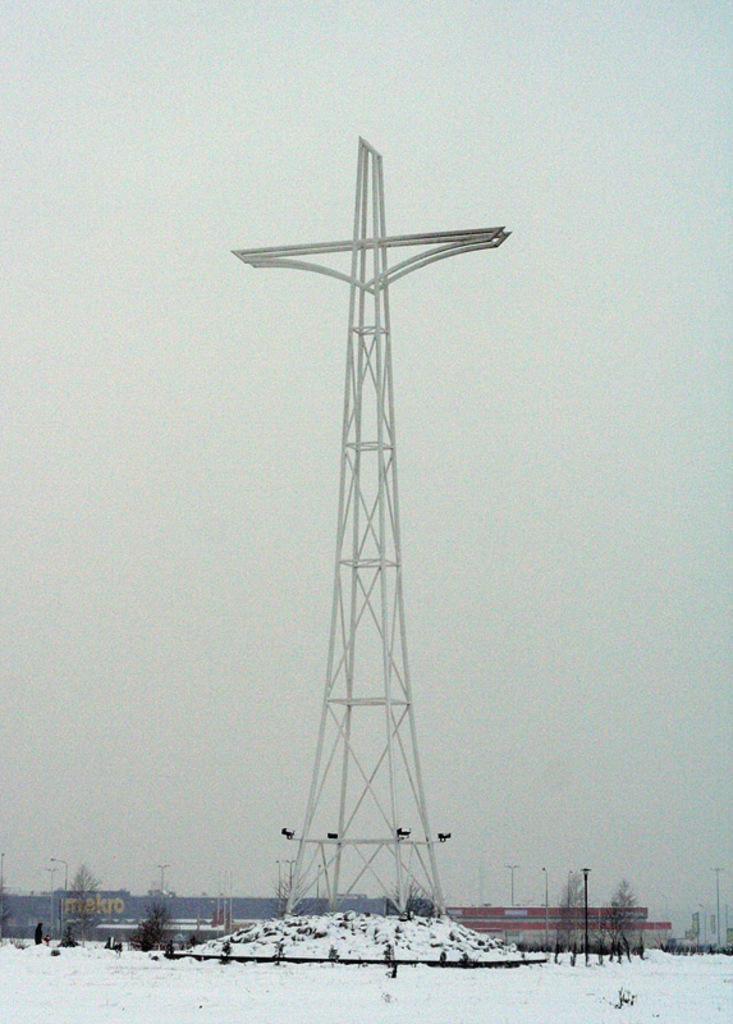What is the main subject in the foreground of the image? There is a tower in the foreground of the image. What can be seen in the background of the image? There are poles, buildings, and the sky visible in the background of the image. How can you describe the ground in the image? There is snow on the bottom of the image. Where is the flower located in the image? There is no flower present in the image. What type of crook can be seen interacting with the poles in the image? There is no crook or interaction with poles depicted in the image. 